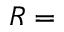Convert formula to latex. <formula><loc_0><loc_0><loc_500><loc_500>R =</formula> 